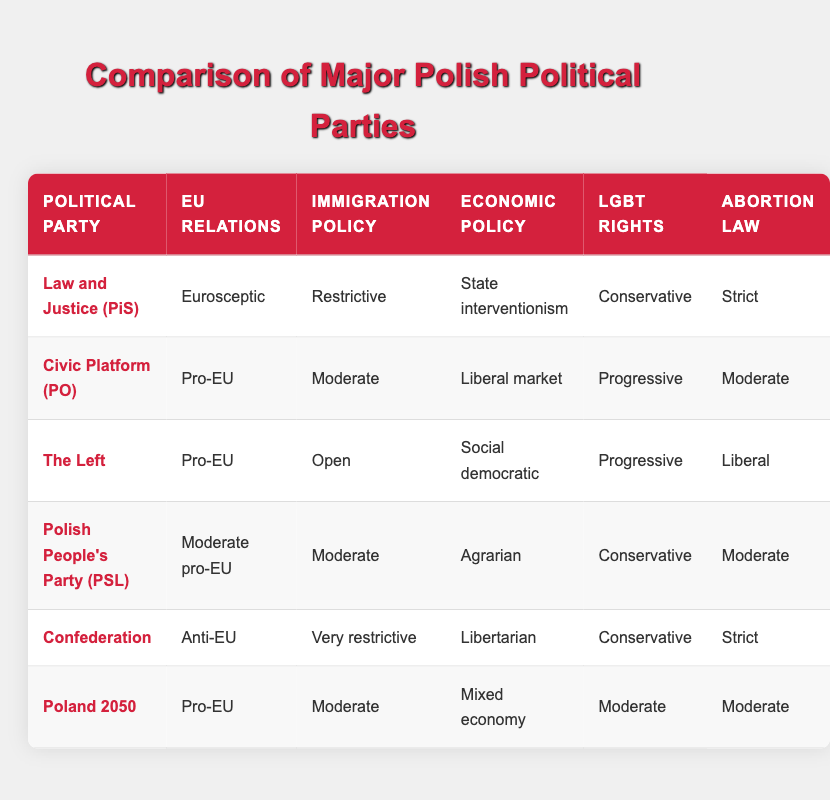What is the stance of Civic Platform (PO) on EU relations? From the table, Civic Platform (PO) is categorized as "Pro-EU."
Answer: Pro-EU Which party has the most restrictive immigration policy? By reviewing the immigration policy column, it can be observed that Confederation has the most restrictive stance with "Very restrictive."
Answer: Confederation How many parties support a mixed economy economic policy? The economic policy column shows that only one party, Poland 2050, has a "Mixed economy" stance. Therefore, the count is 1.
Answer: 1 Is The Left pro-EU? According to the table, The Left is listed as "Pro-EU," indicating support for EU relations.
Answer: Yes What are the abortion law stances of the parties that support pro-EU relations? The parties that are pro-EU are Civic Platform (PO), The Left, and Poland 2050. Their stances on abortion law are Moderate, Liberal, and Moderate, respectively.
Answer: Moderate, Liberal, Moderate Which party is anti-EU and has a strict abortion law? The table identifies Confederation as anti-EU and lists its abortion law stance as "Strict."
Answer: Confederation What is the difference in economic policy between Law and Justice (PiS) and Civic Platform (PO)? Law and Justice (PiS) has a "State interventionism" policy, while Civic Platform (PO) adopts a "Liberal market" approach, showing a difference in economic approaches promoting state control versus market liberalization.
Answer: State interventionism vs. Liberal market How many parties have a conservative stance on LGBT rights? By examining the LGBT rights column, two parties have a conservative stance: Law and Justice (PiS) and Confederation, totaling two parties.
Answer: 2 What is the average stance on immigration policy among parties that are not Eurosceptic? The candidate parties not classified as Eurosceptic are Civic Platform (PO), The Left, Polish People's Party (PSL), and Poland 2050. Their immigration policies are Moderate, Open, Moderate, and Moderate, respectively. To find the average, we classify the policies: Moderate = 2, Open = 3, and each Moderate = 2 yields an average ranking of (2 + 3 + 2 + 2) / 4 = 2.25. However, as immigration policies don't inherently have numerical values, we'll count only the types which yields an average of 2.
Answer: 2.25 